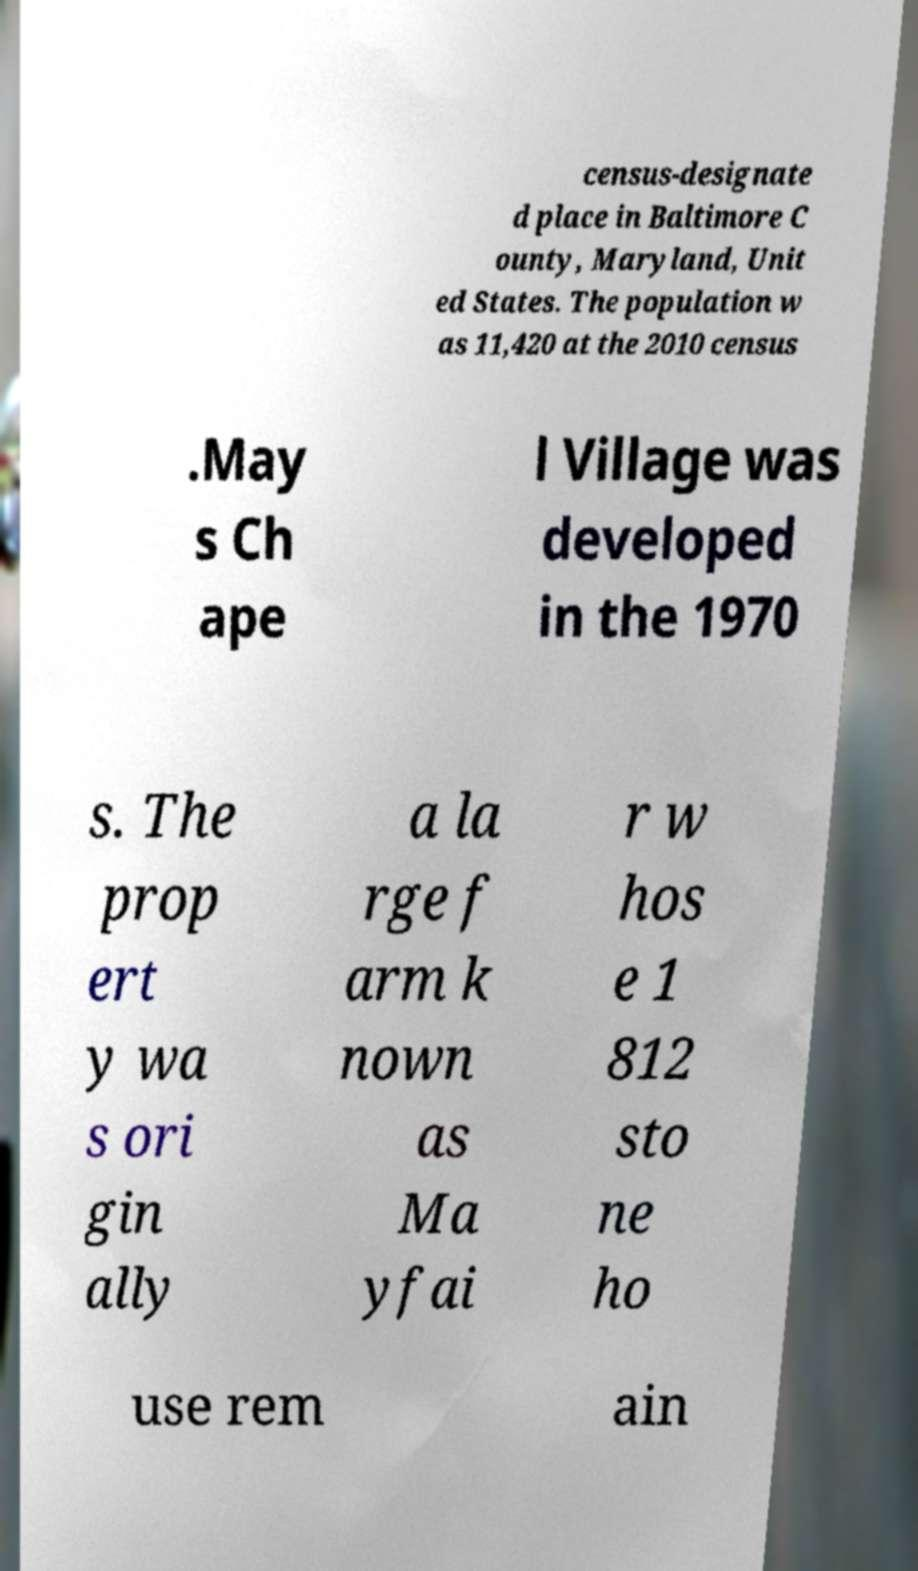Can you read and provide the text displayed in the image?This photo seems to have some interesting text. Can you extract and type it out for me? census-designate d place in Baltimore C ounty, Maryland, Unit ed States. The population w as 11,420 at the 2010 census .May s Ch ape l Village was developed in the 1970 s. The prop ert y wa s ori gin ally a la rge f arm k nown as Ma yfai r w hos e 1 812 sto ne ho use rem ain 